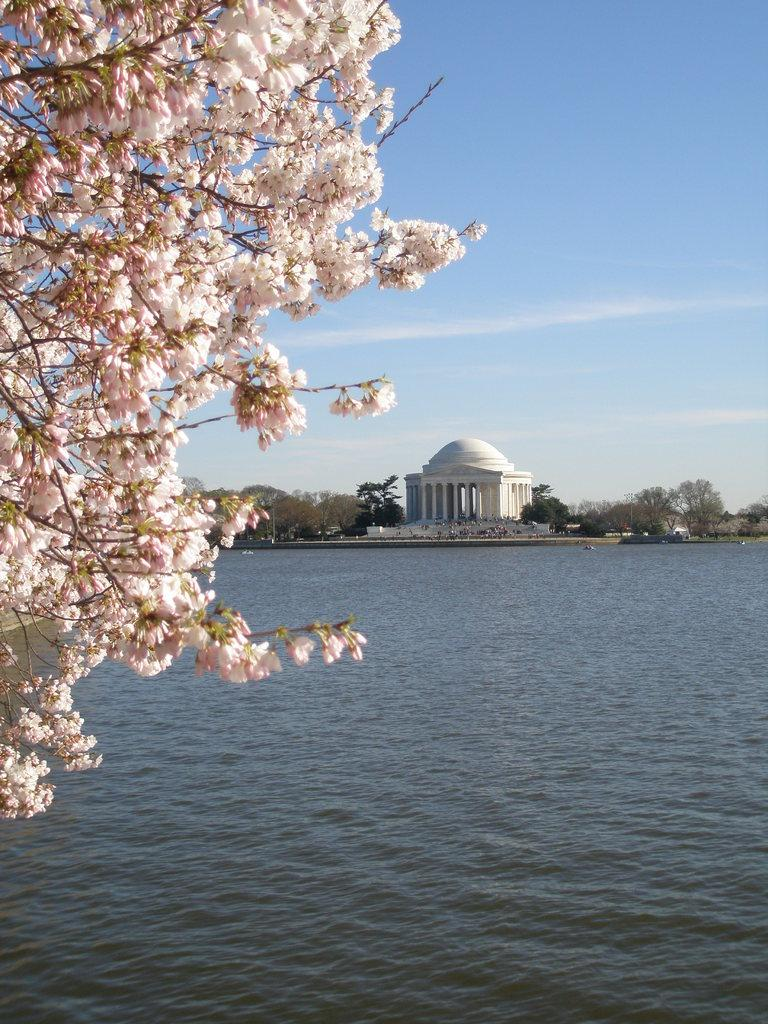What type of natural feature is present in the image? There is a lake in the image. What can be seen on the left side of the image? There are blossoms on the left side of the image. What is visible in the background of the image? There is a building, trees, and the sky visible in the background of the image. What type of holiday is being celebrated in the image? There is no indication of a holiday being celebrated in the image. Can you see any mountains in the image? There are no mountains visible in the image; it features a lake, blossoms, and a background with a building, trees, and the sky. 